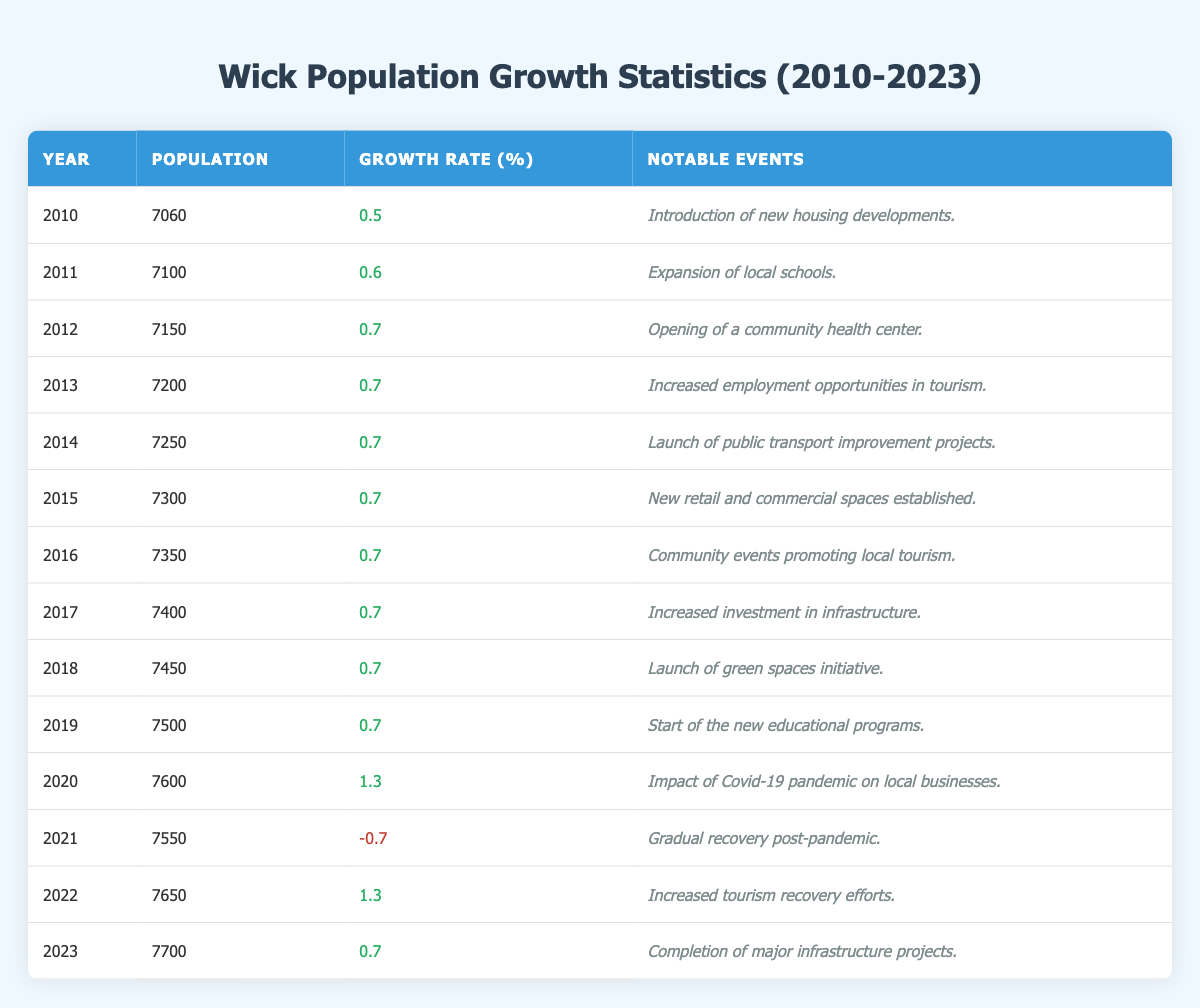What was the population of Wick in 2010? The table shows that in 2010, the population was recorded as 7060.
Answer: 7060 What notable event occurred in Wick in 2012? According to the table, the notable event in 2012 was the opening of a community health center.
Answer: Opening of a community health center What is the growth rate for Wick in 2021? The table indicates that the growth rate in 2021 was -0.7%.
Answer: -0.7% Which year saw the highest population growth rate? By examining the table, the highest growth rate occurred in 2020 with a rate of 1.3%.
Answer: 2020 What was the average population in Wick from 2010 to 2023? The populations from 2010 to 2023 are summed (7060 + 7100 + 7150 + 7200 + 7250 + 7300 + 7350 + 7400 + 7450 + 7500 + 7600 + 7550 + 7650 + 7700) = 104,200. There are 14 data points, so the average is 104,200 / 14 = 7,400.
Answer: 7400 Was there any year where the population decreased compared to the previous year? Yes, the table shows a decrease in population in 2021 when it dropped to 7550 from 7600 in 2020.
Answer: Yes What notable event coincided with the highest population of Wick? The highest population recorded was 7700 in 2023, which coincided with the completion of major infrastructure projects.
Answer: Completion of major infrastructure projects What was the overall trend in population growth rate from 2010 to 2023? The growth rates primarily show positive values, with fluctuations in 2021 (negative) and 2020 (highest positive), suggesting a trend of gradual growth with short-term declines.
Answer: Gradual growth with fluctuations How much did the population increase from 2010 to 2023? The population in 2010 was 7060 and in 2023 it was 7700. Therefore, the increase is 7700 - 7060 = 640.
Answer: 640 Which year marked the introduction of new housing developments? The table indicates that the introduction of new housing developments occurred in 2010.
Answer: 2010 What was the population in 2019 compared to the population in 2012? In 2019, the population was 7500, while in 2012 it was 7150. The difference is 7500 - 7150 = 350, so the population increased by 350.
Answer: Increased by 350 In how many years did the population of Wick experience a growth rate of 0.7%? According to the table, the population had a growth rate of 0.7% for 9 years from 2012 to 2019, and again in 2023, totaling 10 years.
Answer: 10 years 